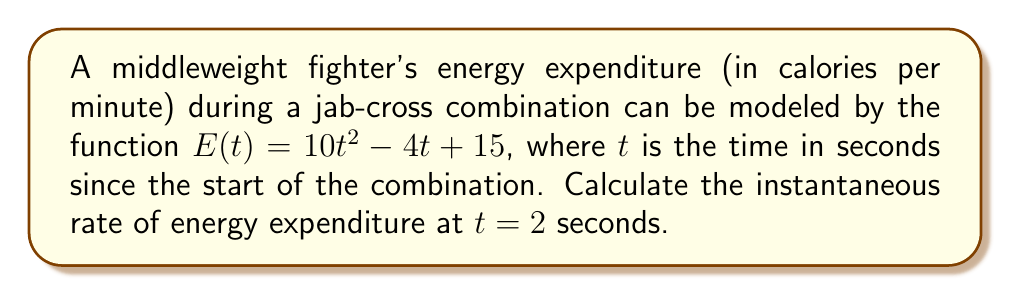Can you answer this question? To find the instantaneous rate of energy expenditure at $t = 2$ seconds, we need to calculate the derivative of the energy function $E(t)$ and evaluate it at $t = 2$.

Step 1: Find the derivative of $E(t)$.
$$\frac{d}{dt}E(t) = \frac{d}{dt}(10t^2 - 4t + 15)$$
$$E'(t) = 20t - 4$$

Step 2: Evaluate the derivative at $t = 2$.
$$E'(2) = 20(2) - 4$$
$$E'(2) = 40 - 4 = 36$$

The instantaneous rate of energy expenditure at $t = 2$ seconds is 36 calories per minute per second.
Answer: 36 cal/min/s 